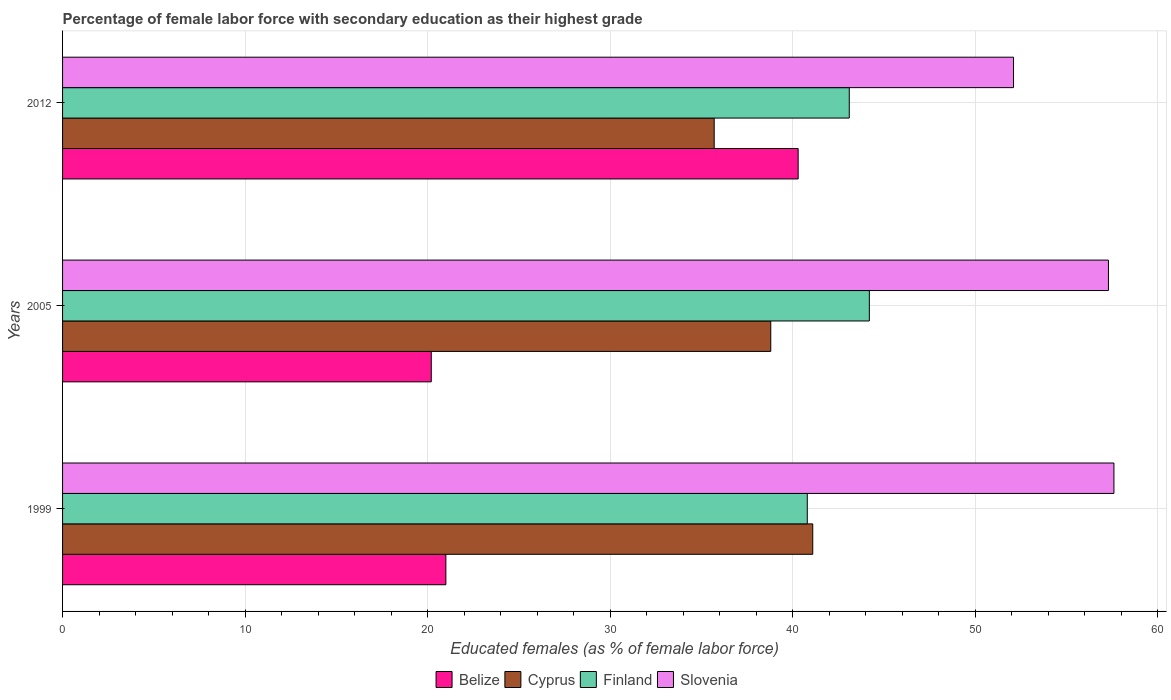How many different coloured bars are there?
Keep it short and to the point. 4. How many bars are there on the 3rd tick from the top?
Your answer should be very brief. 4. How many bars are there on the 2nd tick from the bottom?
Make the answer very short. 4. What is the label of the 2nd group of bars from the top?
Keep it short and to the point. 2005. In how many cases, is the number of bars for a given year not equal to the number of legend labels?
Ensure brevity in your answer.  0. What is the percentage of female labor force with secondary education in Finland in 2012?
Keep it short and to the point. 43.1. Across all years, what is the maximum percentage of female labor force with secondary education in Slovenia?
Keep it short and to the point. 57.6. Across all years, what is the minimum percentage of female labor force with secondary education in Slovenia?
Keep it short and to the point. 52.1. In which year was the percentage of female labor force with secondary education in Belize maximum?
Your answer should be very brief. 2012. What is the total percentage of female labor force with secondary education in Belize in the graph?
Offer a very short reply. 81.5. What is the difference between the percentage of female labor force with secondary education in Slovenia in 1999 and the percentage of female labor force with secondary education in Cyprus in 2012?
Your answer should be very brief. 21.9. What is the average percentage of female labor force with secondary education in Belize per year?
Your answer should be very brief. 27.17. In the year 2012, what is the difference between the percentage of female labor force with secondary education in Belize and percentage of female labor force with secondary education in Slovenia?
Give a very brief answer. -11.8. In how many years, is the percentage of female labor force with secondary education in Finland greater than 52 %?
Your response must be concise. 0. What is the ratio of the percentage of female labor force with secondary education in Cyprus in 1999 to that in 2005?
Your answer should be compact. 1.06. What is the difference between the highest and the second highest percentage of female labor force with secondary education in Finland?
Your response must be concise. 1.1. In how many years, is the percentage of female labor force with secondary education in Slovenia greater than the average percentage of female labor force with secondary education in Slovenia taken over all years?
Keep it short and to the point. 2. Is the sum of the percentage of female labor force with secondary education in Belize in 1999 and 2005 greater than the maximum percentage of female labor force with secondary education in Cyprus across all years?
Your answer should be very brief. Yes. What does the 1st bar from the top in 2012 represents?
Your response must be concise. Slovenia. What does the 1st bar from the bottom in 2012 represents?
Your answer should be very brief. Belize. How many bars are there?
Offer a very short reply. 12. What is the difference between two consecutive major ticks on the X-axis?
Give a very brief answer. 10. Are the values on the major ticks of X-axis written in scientific E-notation?
Provide a succinct answer. No. Does the graph contain any zero values?
Offer a terse response. No. What is the title of the graph?
Provide a succinct answer. Percentage of female labor force with secondary education as their highest grade. What is the label or title of the X-axis?
Make the answer very short. Educated females (as % of female labor force). What is the label or title of the Y-axis?
Your answer should be compact. Years. What is the Educated females (as % of female labor force) of Belize in 1999?
Ensure brevity in your answer.  21. What is the Educated females (as % of female labor force) of Cyprus in 1999?
Provide a succinct answer. 41.1. What is the Educated females (as % of female labor force) of Finland in 1999?
Provide a succinct answer. 40.8. What is the Educated females (as % of female labor force) in Slovenia in 1999?
Your answer should be very brief. 57.6. What is the Educated females (as % of female labor force) of Belize in 2005?
Your answer should be compact. 20.2. What is the Educated females (as % of female labor force) in Cyprus in 2005?
Your response must be concise. 38.8. What is the Educated females (as % of female labor force) in Finland in 2005?
Your answer should be compact. 44.2. What is the Educated females (as % of female labor force) of Slovenia in 2005?
Make the answer very short. 57.3. What is the Educated females (as % of female labor force) of Belize in 2012?
Offer a very short reply. 40.3. What is the Educated females (as % of female labor force) of Cyprus in 2012?
Give a very brief answer. 35.7. What is the Educated females (as % of female labor force) in Finland in 2012?
Provide a short and direct response. 43.1. What is the Educated females (as % of female labor force) of Slovenia in 2012?
Your response must be concise. 52.1. Across all years, what is the maximum Educated females (as % of female labor force) of Belize?
Make the answer very short. 40.3. Across all years, what is the maximum Educated females (as % of female labor force) of Cyprus?
Provide a short and direct response. 41.1. Across all years, what is the maximum Educated females (as % of female labor force) of Finland?
Offer a very short reply. 44.2. Across all years, what is the maximum Educated females (as % of female labor force) in Slovenia?
Make the answer very short. 57.6. Across all years, what is the minimum Educated females (as % of female labor force) in Belize?
Your answer should be very brief. 20.2. Across all years, what is the minimum Educated females (as % of female labor force) of Cyprus?
Your response must be concise. 35.7. Across all years, what is the minimum Educated females (as % of female labor force) of Finland?
Provide a succinct answer. 40.8. Across all years, what is the minimum Educated females (as % of female labor force) in Slovenia?
Make the answer very short. 52.1. What is the total Educated females (as % of female labor force) of Belize in the graph?
Make the answer very short. 81.5. What is the total Educated females (as % of female labor force) of Cyprus in the graph?
Ensure brevity in your answer.  115.6. What is the total Educated females (as % of female labor force) of Finland in the graph?
Your answer should be compact. 128.1. What is the total Educated females (as % of female labor force) of Slovenia in the graph?
Your response must be concise. 167. What is the difference between the Educated females (as % of female labor force) in Belize in 1999 and that in 2005?
Offer a terse response. 0.8. What is the difference between the Educated females (as % of female labor force) in Slovenia in 1999 and that in 2005?
Offer a very short reply. 0.3. What is the difference between the Educated females (as % of female labor force) in Belize in 1999 and that in 2012?
Keep it short and to the point. -19.3. What is the difference between the Educated females (as % of female labor force) in Belize in 2005 and that in 2012?
Keep it short and to the point. -20.1. What is the difference between the Educated females (as % of female labor force) in Cyprus in 2005 and that in 2012?
Provide a short and direct response. 3.1. What is the difference between the Educated females (as % of female labor force) in Finland in 2005 and that in 2012?
Your answer should be very brief. 1.1. What is the difference between the Educated females (as % of female labor force) in Belize in 1999 and the Educated females (as % of female labor force) in Cyprus in 2005?
Make the answer very short. -17.8. What is the difference between the Educated females (as % of female labor force) in Belize in 1999 and the Educated females (as % of female labor force) in Finland in 2005?
Your response must be concise. -23.2. What is the difference between the Educated females (as % of female labor force) in Belize in 1999 and the Educated females (as % of female labor force) in Slovenia in 2005?
Your response must be concise. -36.3. What is the difference between the Educated females (as % of female labor force) in Cyprus in 1999 and the Educated females (as % of female labor force) in Finland in 2005?
Your answer should be compact. -3.1. What is the difference between the Educated females (as % of female labor force) of Cyprus in 1999 and the Educated females (as % of female labor force) of Slovenia in 2005?
Give a very brief answer. -16.2. What is the difference between the Educated females (as % of female labor force) of Finland in 1999 and the Educated females (as % of female labor force) of Slovenia in 2005?
Ensure brevity in your answer.  -16.5. What is the difference between the Educated females (as % of female labor force) of Belize in 1999 and the Educated females (as % of female labor force) of Cyprus in 2012?
Your answer should be very brief. -14.7. What is the difference between the Educated females (as % of female labor force) of Belize in 1999 and the Educated females (as % of female labor force) of Finland in 2012?
Provide a succinct answer. -22.1. What is the difference between the Educated females (as % of female labor force) of Belize in 1999 and the Educated females (as % of female labor force) of Slovenia in 2012?
Give a very brief answer. -31.1. What is the difference between the Educated females (as % of female labor force) in Cyprus in 1999 and the Educated females (as % of female labor force) in Slovenia in 2012?
Offer a very short reply. -11. What is the difference between the Educated females (as % of female labor force) in Belize in 2005 and the Educated females (as % of female labor force) in Cyprus in 2012?
Offer a terse response. -15.5. What is the difference between the Educated females (as % of female labor force) of Belize in 2005 and the Educated females (as % of female labor force) of Finland in 2012?
Keep it short and to the point. -22.9. What is the difference between the Educated females (as % of female labor force) of Belize in 2005 and the Educated females (as % of female labor force) of Slovenia in 2012?
Your answer should be compact. -31.9. What is the difference between the Educated females (as % of female labor force) of Cyprus in 2005 and the Educated females (as % of female labor force) of Slovenia in 2012?
Provide a short and direct response. -13.3. What is the difference between the Educated females (as % of female labor force) of Finland in 2005 and the Educated females (as % of female labor force) of Slovenia in 2012?
Offer a very short reply. -7.9. What is the average Educated females (as % of female labor force) in Belize per year?
Your response must be concise. 27.17. What is the average Educated females (as % of female labor force) in Cyprus per year?
Give a very brief answer. 38.53. What is the average Educated females (as % of female labor force) in Finland per year?
Offer a very short reply. 42.7. What is the average Educated females (as % of female labor force) of Slovenia per year?
Offer a very short reply. 55.67. In the year 1999, what is the difference between the Educated females (as % of female labor force) of Belize and Educated females (as % of female labor force) of Cyprus?
Ensure brevity in your answer.  -20.1. In the year 1999, what is the difference between the Educated females (as % of female labor force) in Belize and Educated females (as % of female labor force) in Finland?
Make the answer very short. -19.8. In the year 1999, what is the difference between the Educated females (as % of female labor force) of Belize and Educated females (as % of female labor force) of Slovenia?
Your answer should be very brief. -36.6. In the year 1999, what is the difference between the Educated females (as % of female labor force) of Cyprus and Educated females (as % of female labor force) of Finland?
Your answer should be very brief. 0.3. In the year 1999, what is the difference between the Educated females (as % of female labor force) in Cyprus and Educated females (as % of female labor force) in Slovenia?
Keep it short and to the point. -16.5. In the year 1999, what is the difference between the Educated females (as % of female labor force) in Finland and Educated females (as % of female labor force) in Slovenia?
Provide a succinct answer. -16.8. In the year 2005, what is the difference between the Educated females (as % of female labor force) in Belize and Educated females (as % of female labor force) in Cyprus?
Provide a succinct answer. -18.6. In the year 2005, what is the difference between the Educated females (as % of female labor force) of Belize and Educated females (as % of female labor force) of Slovenia?
Provide a succinct answer. -37.1. In the year 2005, what is the difference between the Educated females (as % of female labor force) of Cyprus and Educated females (as % of female labor force) of Slovenia?
Ensure brevity in your answer.  -18.5. In the year 2012, what is the difference between the Educated females (as % of female labor force) of Belize and Educated females (as % of female labor force) of Finland?
Make the answer very short. -2.8. In the year 2012, what is the difference between the Educated females (as % of female labor force) in Cyprus and Educated females (as % of female labor force) in Finland?
Your answer should be compact. -7.4. In the year 2012, what is the difference between the Educated females (as % of female labor force) of Cyprus and Educated females (as % of female labor force) of Slovenia?
Your answer should be compact. -16.4. In the year 2012, what is the difference between the Educated females (as % of female labor force) of Finland and Educated females (as % of female labor force) of Slovenia?
Offer a very short reply. -9. What is the ratio of the Educated females (as % of female labor force) of Belize in 1999 to that in 2005?
Give a very brief answer. 1.04. What is the ratio of the Educated females (as % of female labor force) in Cyprus in 1999 to that in 2005?
Make the answer very short. 1.06. What is the ratio of the Educated females (as % of female labor force) in Finland in 1999 to that in 2005?
Ensure brevity in your answer.  0.92. What is the ratio of the Educated females (as % of female labor force) of Belize in 1999 to that in 2012?
Your response must be concise. 0.52. What is the ratio of the Educated females (as % of female labor force) of Cyprus in 1999 to that in 2012?
Provide a succinct answer. 1.15. What is the ratio of the Educated females (as % of female labor force) of Finland in 1999 to that in 2012?
Offer a very short reply. 0.95. What is the ratio of the Educated females (as % of female labor force) in Slovenia in 1999 to that in 2012?
Offer a terse response. 1.11. What is the ratio of the Educated females (as % of female labor force) of Belize in 2005 to that in 2012?
Give a very brief answer. 0.5. What is the ratio of the Educated females (as % of female labor force) in Cyprus in 2005 to that in 2012?
Ensure brevity in your answer.  1.09. What is the ratio of the Educated females (as % of female labor force) in Finland in 2005 to that in 2012?
Provide a succinct answer. 1.03. What is the ratio of the Educated females (as % of female labor force) of Slovenia in 2005 to that in 2012?
Your answer should be compact. 1.1. What is the difference between the highest and the second highest Educated females (as % of female labor force) of Belize?
Provide a short and direct response. 19.3. What is the difference between the highest and the second highest Educated females (as % of female labor force) in Cyprus?
Offer a terse response. 2.3. What is the difference between the highest and the second highest Educated females (as % of female labor force) in Finland?
Keep it short and to the point. 1.1. What is the difference between the highest and the lowest Educated females (as % of female labor force) of Belize?
Provide a short and direct response. 20.1. What is the difference between the highest and the lowest Educated females (as % of female labor force) in Cyprus?
Ensure brevity in your answer.  5.4. What is the difference between the highest and the lowest Educated females (as % of female labor force) in Finland?
Give a very brief answer. 3.4. 